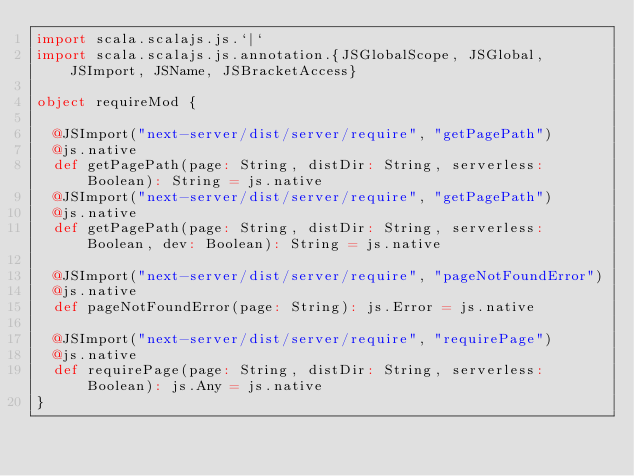Convert code to text. <code><loc_0><loc_0><loc_500><loc_500><_Scala_>import scala.scalajs.js.`|`
import scala.scalajs.js.annotation.{JSGlobalScope, JSGlobal, JSImport, JSName, JSBracketAccess}

object requireMod {
  
  @JSImport("next-server/dist/server/require", "getPagePath")
  @js.native
  def getPagePath(page: String, distDir: String, serverless: Boolean): String = js.native
  @JSImport("next-server/dist/server/require", "getPagePath")
  @js.native
  def getPagePath(page: String, distDir: String, serverless: Boolean, dev: Boolean): String = js.native
  
  @JSImport("next-server/dist/server/require", "pageNotFoundError")
  @js.native
  def pageNotFoundError(page: String): js.Error = js.native
  
  @JSImport("next-server/dist/server/require", "requirePage")
  @js.native
  def requirePage(page: String, distDir: String, serverless: Boolean): js.Any = js.native
}
</code> 